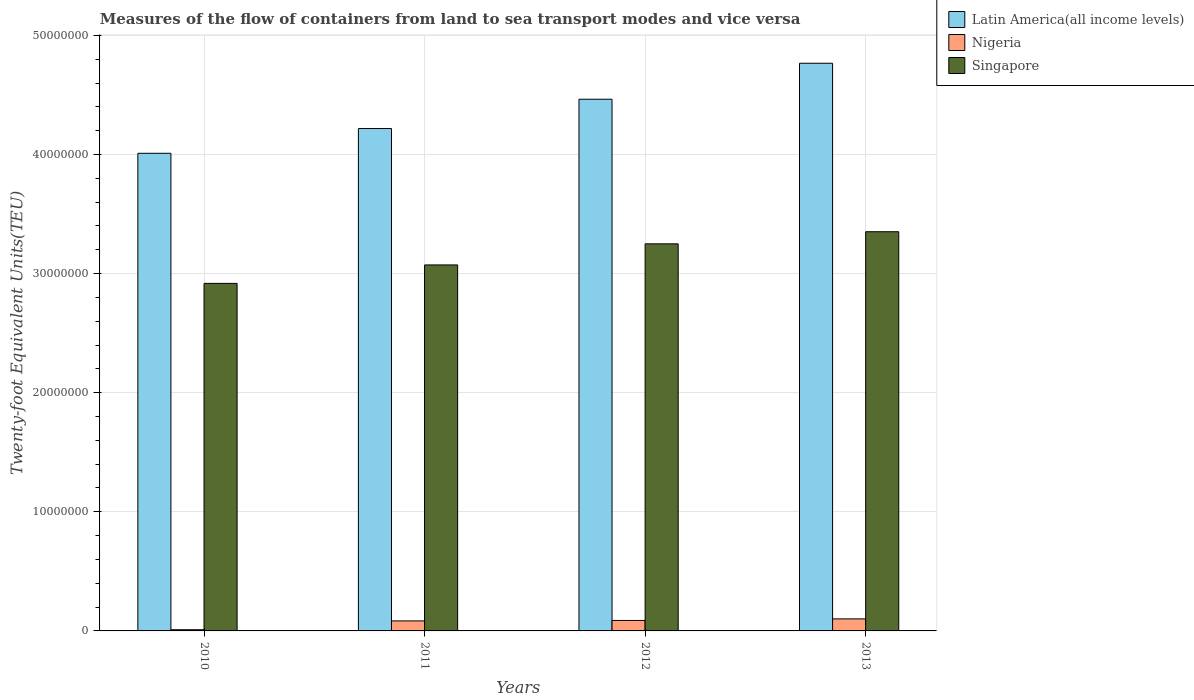How many groups of bars are there?
Provide a succinct answer. 4. Are the number of bars on each tick of the X-axis equal?
Your answer should be compact. Yes. In how many cases, is the number of bars for a given year not equal to the number of legend labels?
Make the answer very short. 0. What is the container port traffic in Nigeria in 2011?
Your answer should be very brief. 8.40e+05. Across all years, what is the maximum container port traffic in Singapore?
Offer a very short reply. 3.35e+07. Across all years, what is the minimum container port traffic in Singapore?
Give a very brief answer. 2.92e+07. In which year was the container port traffic in Singapore minimum?
Keep it short and to the point. 2010. What is the total container port traffic in Singapore in the graph?
Your answer should be very brief. 1.26e+08. What is the difference between the container port traffic in Singapore in 2010 and that in 2013?
Ensure brevity in your answer.  -4.34e+06. What is the difference between the container port traffic in Latin America(all income levels) in 2011 and the container port traffic in Nigeria in 2012?
Your answer should be compact. 4.13e+07. What is the average container port traffic in Singapore per year?
Ensure brevity in your answer.  3.15e+07. In the year 2011, what is the difference between the container port traffic in Singapore and container port traffic in Latin America(all income levels)?
Your answer should be compact. -1.15e+07. In how many years, is the container port traffic in Nigeria greater than 46000000 TEU?
Provide a succinct answer. 0. What is the ratio of the container port traffic in Singapore in 2010 to that in 2011?
Make the answer very short. 0.95. Is the difference between the container port traffic in Singapore in 2010 and 2012 greater than the difference between the container port traffic in Latin America(all income levels) in 2010 and 2012?
Your answer should be compact. Yes. What is the difference between the highest and the second highest container port traffic in Singapore?
Ensure brevity in your answer.  1.02e+06. What is the difference between the highest and the lowest container port traffic in Latin America(all income levels)?
Your response must be concise. 7.56e+06. In how many years, is the container port traffic in Singapore greater than the average container port traffic in Singapore taken over all years?
Provide a short and direct response. 2. Is the sum of the container port traffic in Nigeria in 2011 and 2012 greater than the maximum container port traffic in Singapore across all years?
Your answer should be compact. No. What does the 2nd bar from the left in 2013 represents?
Provide a succinct answer. Nigeria. What does the 1st bar from the right in 2010 represents?
Your answer should be very brief. Singapore. Is it the case that in every year, the sum of the container port traffic in Latin America(all income levels) and container port traffic in Singapore is greater than the container port traffic in Nigeria?
Provide a short and direct response. Yes. How many bars are there?
Make the answer very short. 12. Are all the bars in the graph horizontal?
Give a very brief answer. No. What is the difference between two consecutive major ticks on the Y-axis?
Give a very brief answer. 1.00e+07. What is the title of the graph?
Ensure brevity in your answer.  Measures of the flow of containers from land to sea transport modes and vice versa. Does "Cameroon" appear as one of the legend labels in the graph?
Your answer should be compact. No. What is the label or title of the Y-axis?
Provide a short and direct response. Twenty-foot Equivalent Units(TEU). What is the Twenty-foot Equivalent Units(TEU) in Latin America(all income levels) in 2010?
Provide a succinct answer. 4.01e+07. What is the Twenty-foot Equivalent Units(TEU) in Nigeria in 2010?
Your response must be concise. 1.01e+05. What is the Twenty-foot Equivalent Units(TEU) in Singapore in 2010?
Give a very brief answer. 2.92e+07. What is the Twenty-foot Equivalent Units(TEU) of Latin America(all income levels) in 2011?
Make the answer very short. 4.22e+07. What is the Twenty-foot Equivalent Units(TEU) in Nigeria in 2011?
Offer a very short reply. 8.40e+05. What is the Twenty-foot Equivalent Units(TEU) in Singapore in 2011?
Offer a very short reply. 3.07e+07. What is the Twenty-foot Equivalent Units(TEU) in Latin America(all income levels) in 2012?
Make the answer very short. 4.46e+07. What is the Twenty-foot Equivalent Units(TEU) in Nigeria in 2012?
Your answer should be very brief. 8.78e+05. What is the Twenty-foot Equivalent Units(TEU) of Singapore in 2012?
Your answer should be compact. 3.25e+07. What is the Twenty-foot Equivalent Units(TEU) of Latin America(all income levels) in 2013?
Give a very brief answer. 4.77e+07. What is the Twenty-foot Equivalent Units(TEU) in Nigeria in 2013?
Ensure brevity in your answer.  1.01e+06. What is the Twenty-foot Equivalent Units(TEU) of Singapore in 2013?
Give a very brief answer. 3.35e+07. Across all years, what is the maximum Twenty-foot Equivalent Units(TEU) in Latin America(all income levels)?
Your response must be concise. 4.77e+07. Across all years, what is the maximum Twenty-foot Equivalent Units(TEU) of Nigeria?
Your response must be concise. 1.01e+06. Across all years, what is the maximum Twenty-foot Equivalent Units(TEU) in Singapore?
Provide a succinct answer. 3.35e+07. Across all years, what is the minimum Twenty-foot Equivalent Units(TEU) in Latin America(all income levels)?
Offer a terse response. 4.01e+07. Across all years, what is the minimum Twenty-foot Equivalent Units(TEU) in Nigeria?
Keep it short and to the point. 1.01e+05. Across all years, what is the minimum Twenty-foot Equivalent Units(TEU) of Singapore?
Your response must be concise. 2.92e+07. What is the total Twenty-foot Equivalent Units(TEU) of Latin America(all income levels) in the graph?
Keep it short and to the point. 1.75e+08. What is the total Twenty-foot Equivalent Units(TEU) of Nigeria in the graph?
Provide a short and direct response. 2.83e+06. What is the total Twenty-foot Equivalent Units(TEU) of Singapore in the graph?
Make the answer very short. 1.26e+08. What is the difference between the Twenty-foot Equivalent Units(TEU) of Latin America(all income levels) in 2010 and that in 2011?
Make the answer very short. -2.08e+06. What is the difference between the Twenty-foot Equivalent Units(TEU) in Nigeria in 2010 and that in 2011?
Make the answer very short. -7.39e+05. What is the difference between the Twenty-foot Equivalent Units(TEU) in Singapore in 2010 and that in 2011?
Your response must be concise. -1.55e+06. What is the difference between the Twenty-foot Equivalent Units(TEU) of Latin America(all income levels) in 2010 and that in 2012?
Offer a terse response. -4.54e+06. What is the difference between the Twenty-foot Equivalent Units(TEU) of Nigeria in 2010 and that in 2012?
Your response must be concise. -7.77e+05. What is the difference between the Twenty-foot Equivalent Units(TEU) in Singapore in 2010 and that in 2012?
Offer a very short reply. -3.32e+06. What is the difference between the Twenty-foot Equivalent Units(TEU) in Latin America(all income levels) in 2010 and that in 2013?
Your answer should be compact. -7.56e+06. What is the difference between the Twenty-foot Equivalent Units(TEU) in Nigeria in 2010 and that in 2013?
Offer a very short reply. -9.10e+05. What is the difference between the Twenty-foot Equivalent Units(TEU) of Singapore in 2010 and that in 2013?
Provide a short and direct response. -4.34e+06. What is the difference between the Twenty-foot Equivalent Units(TEU) of Latin America(all income levels) in 2011 and that in 2012?
Offer a terse response. -2.46e+06. What is the difference between the Twenty-foot Equivalent Units(TEU) in Nigeria in 2011 and that in 2012?
Your response must be concise. -3.78e+04. What is the difference between the Twenty-foot Equivalent Units(TEU) of Singapore in 2011 and that in 2012?
Keep it short and to the point. -1.77e+06. What is the difference between the Twenty-foot Equivalent Units(TEU) of Latin America(all income levels) in 2011 and that in 2013?
Your answer should be very brief. -5.48e+06. What is the difference between the Twenty-foot Equivalent Units(TEU) in Nigeria in 2011 and that in 2013?
Offer a terse response. -1.71e+05. What is the difference between the Twenty-foot Equivalent Units(TEU) in Singapore in 2011 and that in 2013?
Provide a succinct answer. -2.79e+06. What is the difference between the Twenty-foot Equivalent Units(TEU) of Latin America(all income levels) in 2012 and that in 2013?
Offer a terse response. -3.02e+06. What is the difference between the Twenty-foot Equivalent Units(TEU) in Nigeria in 2012 and that in 2013?
Ensure brevity in your answer.  -1.33e+05. What is the difference between the Twenty-foot Equivalent Units(TEU) of Singapore in 2012 and that in 2013?
Keep it short and to the point. -1.02e+06. What is the difference between the Twenty-foot Equivalent Units(TEU) of Latin America(all income levels) in 2010 and the Twenty-foot Equivalent Units(TEU) of Nigeria in 2011?
Keep it short and to the point. 3.93e+07. What is the difference between the Twenty-foot Equivalent Units(TEU) of Latin America(all income levels) in 2010 and the Twenty-foot Equivalent Units(TEU) of Singapore in 2011?
Provide a succinct answer. 9.37e+06. What is the difference between the Twenty-foot Equivalent Units(TEU) in Nigeria in 2010 and the Twenty-foot Equivalent Units(TEU) in Singapore in 2011?
Your response must be concise. -3.06e+07. What is the difference between the Twenty-foot Equivalent Units(TEU) of Latin America(all income levels) in 2010 and the Twenty-foot Equivalent Units(TEU) of Nigeria in 2012?
Offer a terse response. 3.92e+07. What is the difference between the Twenty-foot Equivalent Units(TEU) of Latin America(all income levels) in 2010 and the Twenty-foot Equivalent Units(TEU) of Singapore in 2012?
Your answer should be very brief. 7.60e+06. What is the difference between the Twenty-foot Equivalent Units(TEU) in Nigeria in 2010 and the Twenty-foot Equivalent Units(TEU) in Singapore in 2012?
Make the answer very short. -3.24e+07. What is the difference between the Twenty-foot Equivalent Units(TEU) in Latin America(all income levels) in 2010 and the Twenty-foot Equivalent Units(TEU) in Nigeria in 2013?
Your response must be concise. 3.91e+07. What is the difference between the Twenty-foot Equivalent Units(TEU) in Latin America(all income levels) in 2010 and the Twenty-foot Equivalent Units(TEU) in Singapore in 2013?
Keep it short and to the point. 6.58e+06. What is the difference between the Twenty-foot Equivalent Units(TEU) of Nigeria in 2010 and the Twenty-foot Equivalent Units(TEU) of Singapore in 2013?
Your response must be concise. -3.34e+07. What is the difference between the Twenty-foot Equivalent Units(TEU) in Latin America(all income levels) in 2011 and the Twenty-foot Equivalent Units(TEU) in Nigeria in 2012?
Your response must be concise. 4.13e+07. What is the difference between the Twenty-foot Equivalent Units(TEU) of Latin America(all income levels) in 2011 and the Twenty-foot Equivalent Units(TEU) of Singapore in 2012?
Your answer should be very brief. 9.68e+06. What is the difference between the Twenty-foot Equivalent Units(TEU) in Nigeria in 2011 and the Twenty-foot Equivalent Units(TEU) in Singapore in 2012?
Offer a terse response. -3.17e+07. What is the difference between the Twenty-foot Equivalent Units(TEU) of Latin America(all income levels) in 2011 and the Twenty-foot Equivalent Units(TEU) of Nigeria in 2013?
Give a very brief answer. 4.12e+07. What is the difference between the Twenty-foot Equivalent Units(TEU) of Latin America(all income levels) in 2011 and the Twenty-foot Equivalent Units(TEU) of Singapore in 2013?
Give a very brief answer. 8.66e+06. What is the difference between the Twenty-foot Equivalent Units(TEU) of Nigeria in 2011 and the Twenty-foot Equivalent Units(TEU) of Singapore in 2013?
Give a very brief answer. -3.27e+07. What is the difference between the Twenty-foot Equivalent Units(TEU) of Latin America(all income levels) in 2012 and the Twenty-foot Equivalent Units(TEU) of Nigeria in 2013?
Your response must be concise. 4.36e+07. What is the difference between the Twenty-foot Equivalent Units(TEU) of Latin America(all income levels) in 2012 and the Twenty-foot Equivalent Units(TEU) of Singapore in 2013?
Your answer should be compact. 1.11e+07. What is the difference between the Twenty-foot Equivalent Units(TEU) in Nigeria in 2012 and the Twenty-foot Equivalent Units(TEU) in Singapore in 2013?
Offer a very short reply. -3.26e+07. What is the average Twenty-foot Equivalent Units(TEU) of Latin America(all income levels) per year?
Your answer should be very brief. 4.36e+07. What is the average Twenty-foot Equivalent Units(TEU) in Nigeria per year?
Provide a short and direct response. 7.07e+05. What is the average Twenty-foot Equivalent Units(TEU) in Singapore per year?
Give a very brief answer. 3.15e+07. In the year 2010, what is the difference between the Twenty-foot Equivalent Units(TEU) in Latin America(all income levels) and Twenty-foot Equivalent Units(TEU) in Nigeria?
Keep it short and to the point. 4.00e+07. In the year 2010, what is the difference between the Twenty-foot Equivalent Units(TEU) in Latin America(all income levels) and Twenty-foot Equivalent Units(TEU) in Singapore?
Offer a terse response. 1.09e+07. In the year 2010, what is the difference between the Twenty-foot Equivalent Units(TEU) in Nigeria and Twenty-foot Equivalent Units(TEU) in Singapore?
Your answer should be compact. -2.91e+07. In the year 2011, what is the difference between the Twenty-foot Equivalent Units(TEU) in Latin America(all income levels) and Twenty-foot Equivalent Units(TEU) in Nigeria?
Offer a very short reply. 4.13e+07. In the year 2011, what is the difference between the Twenty-foot Equivalent Units(TEU) in Latin America(all income levels) and Twenty-foot Equivalent Units(TEU) in Singapore?
Offer a terse response. 1.15e+07. In the year 2011, what is the difference between the Twenty-foot Equivalent Units(TEU) of Nigeria and Twenty-foot Equivalent Units(TEU) of Singapore?
Offer a terse response. -2.99e+07. In the year 2012, what is the difference between the Twenty-foot Equivalent Units(TEU) in Latin America(all income levels) and Twenty-foot Equivalent Units(TEU) in Nigeria?
Your response must be concise. 4.38e+07. In the year 2012, what is the difference between the Twenty-foot Equivalent Units(TEU) in Latin America(all income levels) and Twenty-foot Equivalent Units(TEU) in Singapore?
Offer a very short reply. 1.21e+07. In the year 2012, what is the difference between the Twenty-foot Equivalent Units(TEU) in Nigeria and Twenty-foot Equivalent Units(TEU) in Singapore?
Provide a short and direct response. -3.16e+07. In the year 2013, what is the difference between the Twenty-foot Equivalent Units(TEU) of Latin America(all income levels) and Twenty-foot Equivalent Units(TEU) of Nigeria?
Keep it short and to the point. 4.66e+07. In the year 2013, what is the difference between the Twenty-foot Equivalent Units(TEU) of Latin America(all income levels) and Twenty-foot Equivalent Units(TEU) of Singapore?
Offer a terse response. 1.41e+07. In the year 2013, what is the difference between the Twenty-foot Equivalent Units(TEU) of Nigeria and Twenty-foot Equivalent Units(TEU) of Singapore?
Your answer should be compact. -3.25e+07. What is the ratio of the Twenty-foot Equivalent Units(TEU) of Latin America(all income levels) in 2010 to that in 2011?
Ensure brevity in your answer.  0.95. What is the ratio of the Twenty-foot Equivalent Units(TEU) in Nigeria in 2010 to that in 2011?
Give a very brief answer. 0.12. What is the ratio of the Twenty-foot Equivalent Units(TEU) of Singapore in 2010 to that in 2011?
Your answer should be compact. 0.95. What is the ratio of the Twenty-foot Equivalent Units(TEU) of Latin America(all income levels) in 2010 to that in 2012?
Provide a short and direct response. 0.9. What is the ratio of the Twenty-foot Equivalent Units(TEU) of Nigeria in 2010 to that in 2012?
Offer a very short reply. 0.12. What is the ratio of the Twenty-foot Equivalent Units(TEU) of Singapore in 2010 to that in 2012?
Your response must be concise. 0.9. What is the ratio of the Twenty-foot Equivalent Units(TEU) in Latin America(all income levels) in 2010 to that in 2013?
Provide a short and direct response. 0.84. What is the ratio of the Twenty-foot Equivalent Units(TEU) in Nigeria in 2010 to that in 2013?
Your answer should be very brief. 0.1. What is the ratio of the Twenty-foot Equivalent Units(TEU) in Singapore in 2010 to that in 2013?
Your answer should be very brief. 0.87. What is the ratio of the Twenty-foot Equivalent Units(TEU) in Latin America(all income levels) in 2011 to that in 2012?
Offer a very short reply. 0.94. What is the ratio of the Twenty-foot Equivalent Units(TEU) of Nigeria in 2011 to that in 2012?
Give a very brief answer. 0.96. What is the ratio of the Twenty-foot Equivalent Units(TEU) in Singapore in 2011 to that in 2012?
Make the answer very short. 0.95. What is the ratio of the Twenty-foot Equivalent Units(TEU) in Latin America(all income levels) in 2011 to that in 2013?
Provide a short and direct response. 0.89. What is the ratio of the Twenty-foot Equivalent Units(TEU) of Nigeria in 2011 to that in 2013?
Make the answer very short. 0.83. What is the ratio of the Twenty-foot Equivalent Units(TEU) in Singapore in 2011 to that in 2013?
Your response must be concise. 0.92. What is the ratio of the Twenty-foot Equivalent Units(TEU) of Latin America(all income levels) in 2012 to that in 2013?
Provide a succinct answer. 0.94. What is the ratio of the Twenty-foot Equivalent Units(TEU) of Nigeria in 2012 to that in 2013?
Your response must be concise. 0.87. What is the ratio of the Twenty-foot Equivalent Units(TEU) in Singapore in 2012 to that in 2013?
Your response must be concise. 0.97. What is the difference between the highest and the second highest Twenty-foot Equivalent Units(TEU) in Latin America(all income levels)?
Your answer should be compact. 3.02e+06. What is the difference between the highest and the second highest Twenty-foot Equivalent Units(TEU) in Nigeria?
Provide a succinct answer. 1.33e+05. What is the difference between the highest and the second highest Twenty-foot Equivalent Units(TEU) in Singapore?
Your answer should be very brief. 1.02e+06. What is the difference between the highest and the lowest Twenty-foot Equivalent Units(TEU) of Latin America(all income levels)?
Make the answer very short. 7.56e+06. What is the difference between the highest and the lowest Twenty-foot Equivalent Units(TEU) of Nigeria?
Your answer should be very brief. 9.10e+05. What is the difference between the highest and the lowest Twenty-foot Equivalent Units(TEU) in Singapore?
Provide a succinct answer. 4.34e+06. 